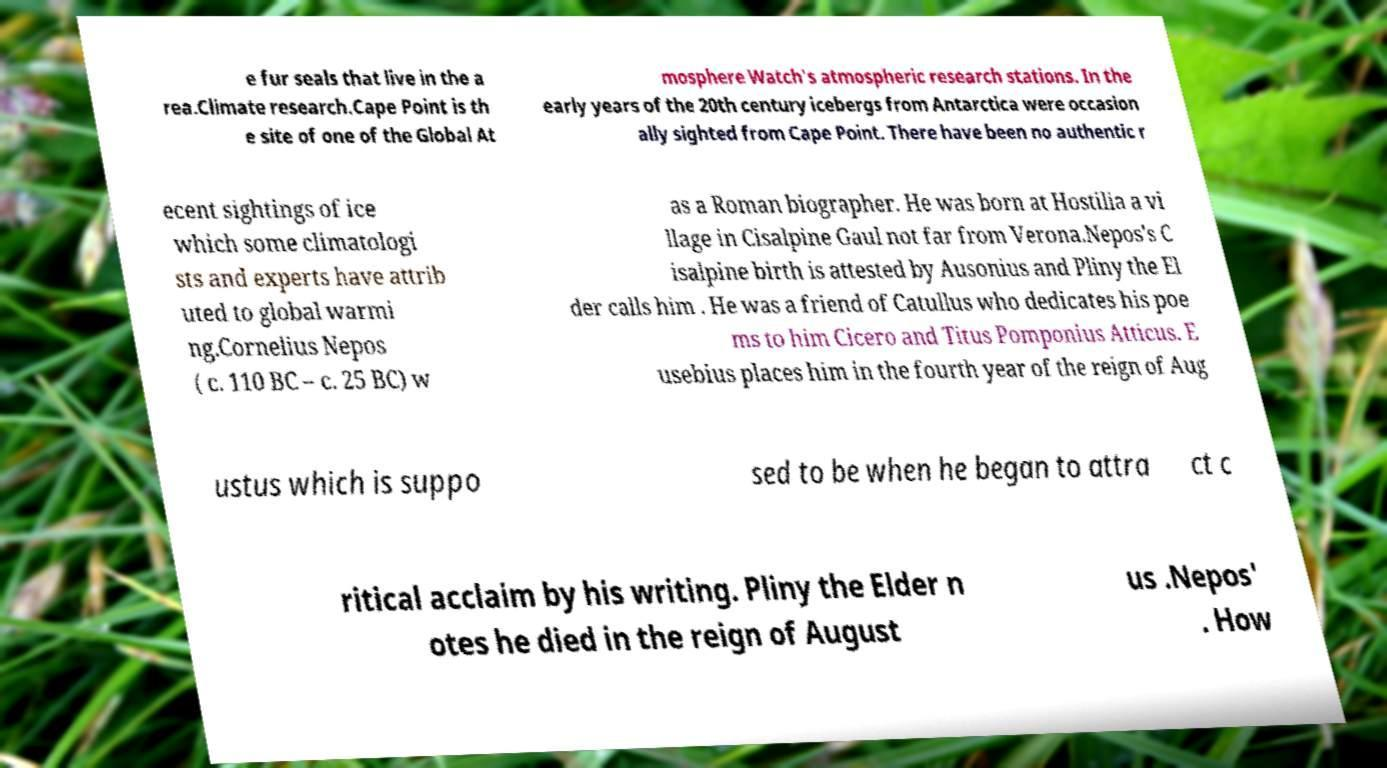What messages or text are displayed in this image? I need them in a readable, typed format. e fur seals that live in the a rea.Climate research.Cape Point is th e site of one of the Global At mosphere Watch's atmospheric research stations. In the early years of the 20th century icebergs from Antarctica were occasion ally sighted from Cape Point. There have been no authentic r ecent sightings of ice which some climatologi sts and experts have attrib uted to global warmi ng.Cornelius Nepos ( c. 110 BC – c. 25 BC) w as a Roman biographer. He was born at Hostilia a vi llage in Cisalpine Gaul not far from Verona.Nepos's C isalpine birth is attested by Ausonius and Pliny the El der calls him . He was a friend of Catullus who dedicates his poe ms to him Cicero and Titus Pomponius Atticus. E usebius places him in the fourth year of the reign of Aug ustus which is suppo sed to be when he began to attra ct c ritical acclaim by his writing. Pliny the Elder n otes he died in the reign of August us .Nepos' . How 